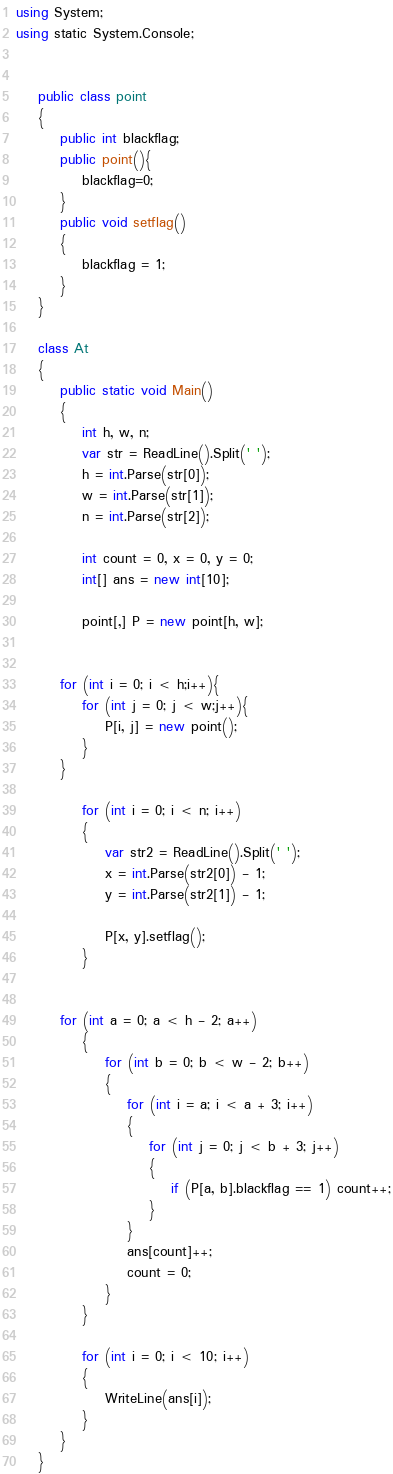Convert code to text. <code><loc_0><loc_0><loc_500><loc_500><_C#_>using System;
using static System.Console;


    public class point
    {
        public int blackflag;
        public point(){
            blackflag=0;
        }
        public void setflag()
        {
            blackflag = 1;
        }
    }

    class At
    {
        public static void Main()
        {
            int h, w, n;
            var str = ReadLine().Split(' ');
            h = int.Parse(str[0]);
            w = int.Parse(str[1]);
            n = int.Parse(str[2]);

            int count = 0, x = 0, y = 0;
            int[] ans = new int[10];

            point[,] P = new point[h, w];


        for (int i = 0; i < h;i++){
            for (int j = 0; j < w;j++){
                P[i, j] = new point();
            }
        }

            for (int i = 0; i < n; i++)
            {
                var str2 = ReadLine().Split(' ');
                x = int.Parse(str2[0]) - 1;
                y = int.Parse(str2[1]) - 1;

                P[x, y].setflag();
            }


        for (int a = 0; a < h - 2; a++)
            {
                for (int b = 0; b < w - 2; b++)
                {
                    for (int i = a; i < a + 3; i++)
                    {
                        for (int j = 0; j < b + 3; j++)
                        {
                            if (P[a, b].blackflag == 1) count++;
                        }
                    }
                    ans[count]++;
                    count = 0;
                }
            }

            for (int i = 0; i < 10; i++)
            {
                WriteLine(ans[i]);
            }
        }
    }
</code> 